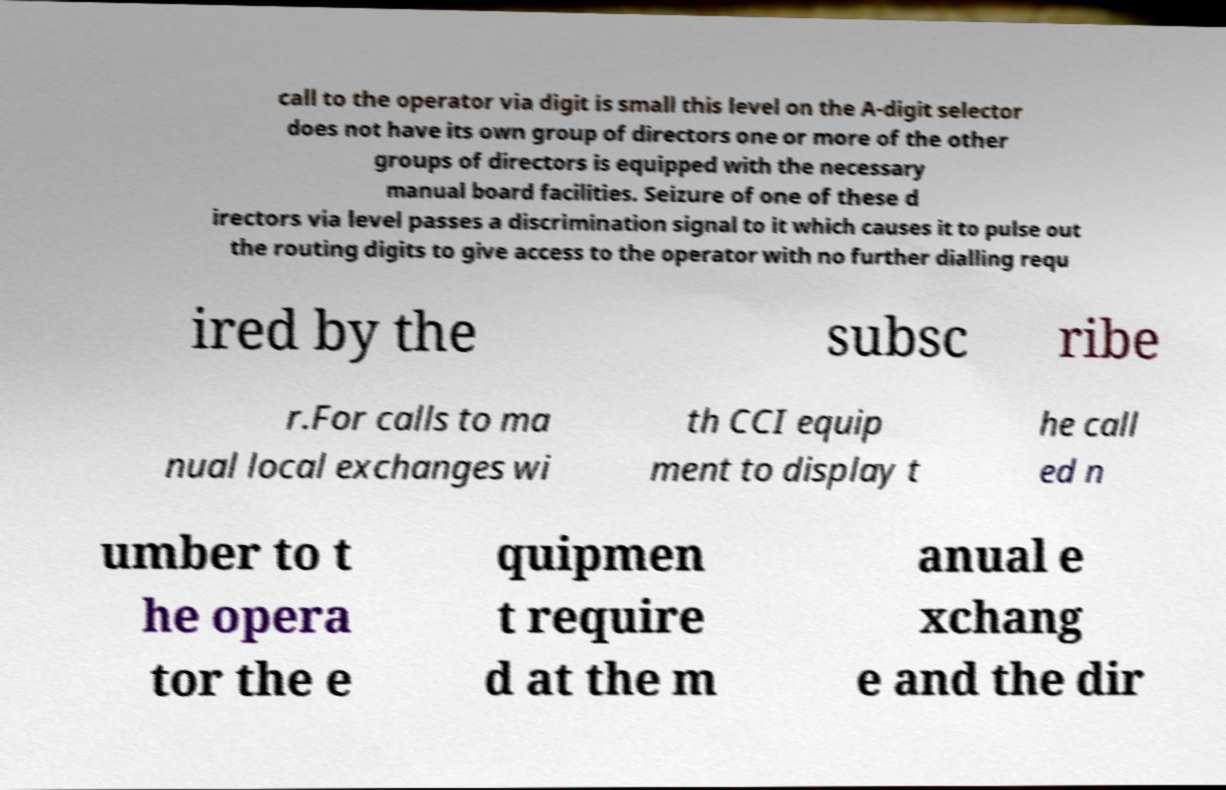For documentation purposes, I need the text within this image transcribed. Could you provide that? call to the operator via digit is small this level on the A-digit selector does not have its own group of directors one or more of the other groups of directors is equipped with the necessary manual board facilities. Seizure of one of these d irectors via level passes a discrimination signal to it which causes it to pulse out the routing digits to give access to the operator with no further dialling requ ired by the subsc ribe r.For calls to ma nual local exchanges wi th CCI equip ment to display t he call ed n umber to t he opera tor the e quipmen t require d at the m anual e xchang e and the dir 